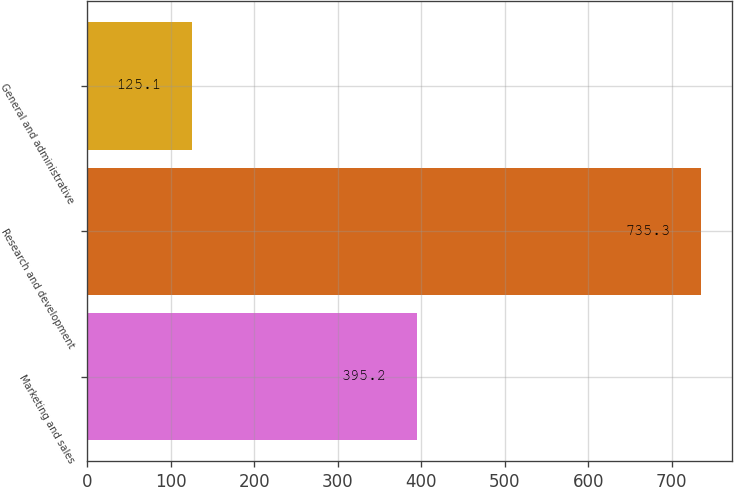Convert chart to OTSL. <chart><loc_0><loc_0><loc_500><loc_500><bar_chart><fcel>Marketing and sales<fcel>Research and development<fcel>General and administrative<nl><fcel>395.2<fcel>735.3<fcel>125.1<nl></chart> 